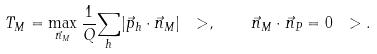<formula> <loc_0><loc_0><loc_500><loc_500>T _ { M } = \max _ { \vec { n } _ { M } } \frac { 1 } { Q } { \sum _ { h } } | \vec { p } _ { h } \cdot \vec { n } _ { M } | \ > , \quad \vec { n } _ { M } \cdot \vec { n } _ { P } = 0 \ > .</formula> 